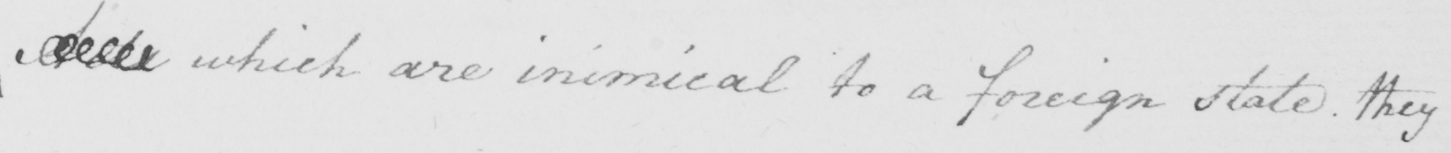Can you tell me what this handwritten text says? All which are inimical to a foreign state they 